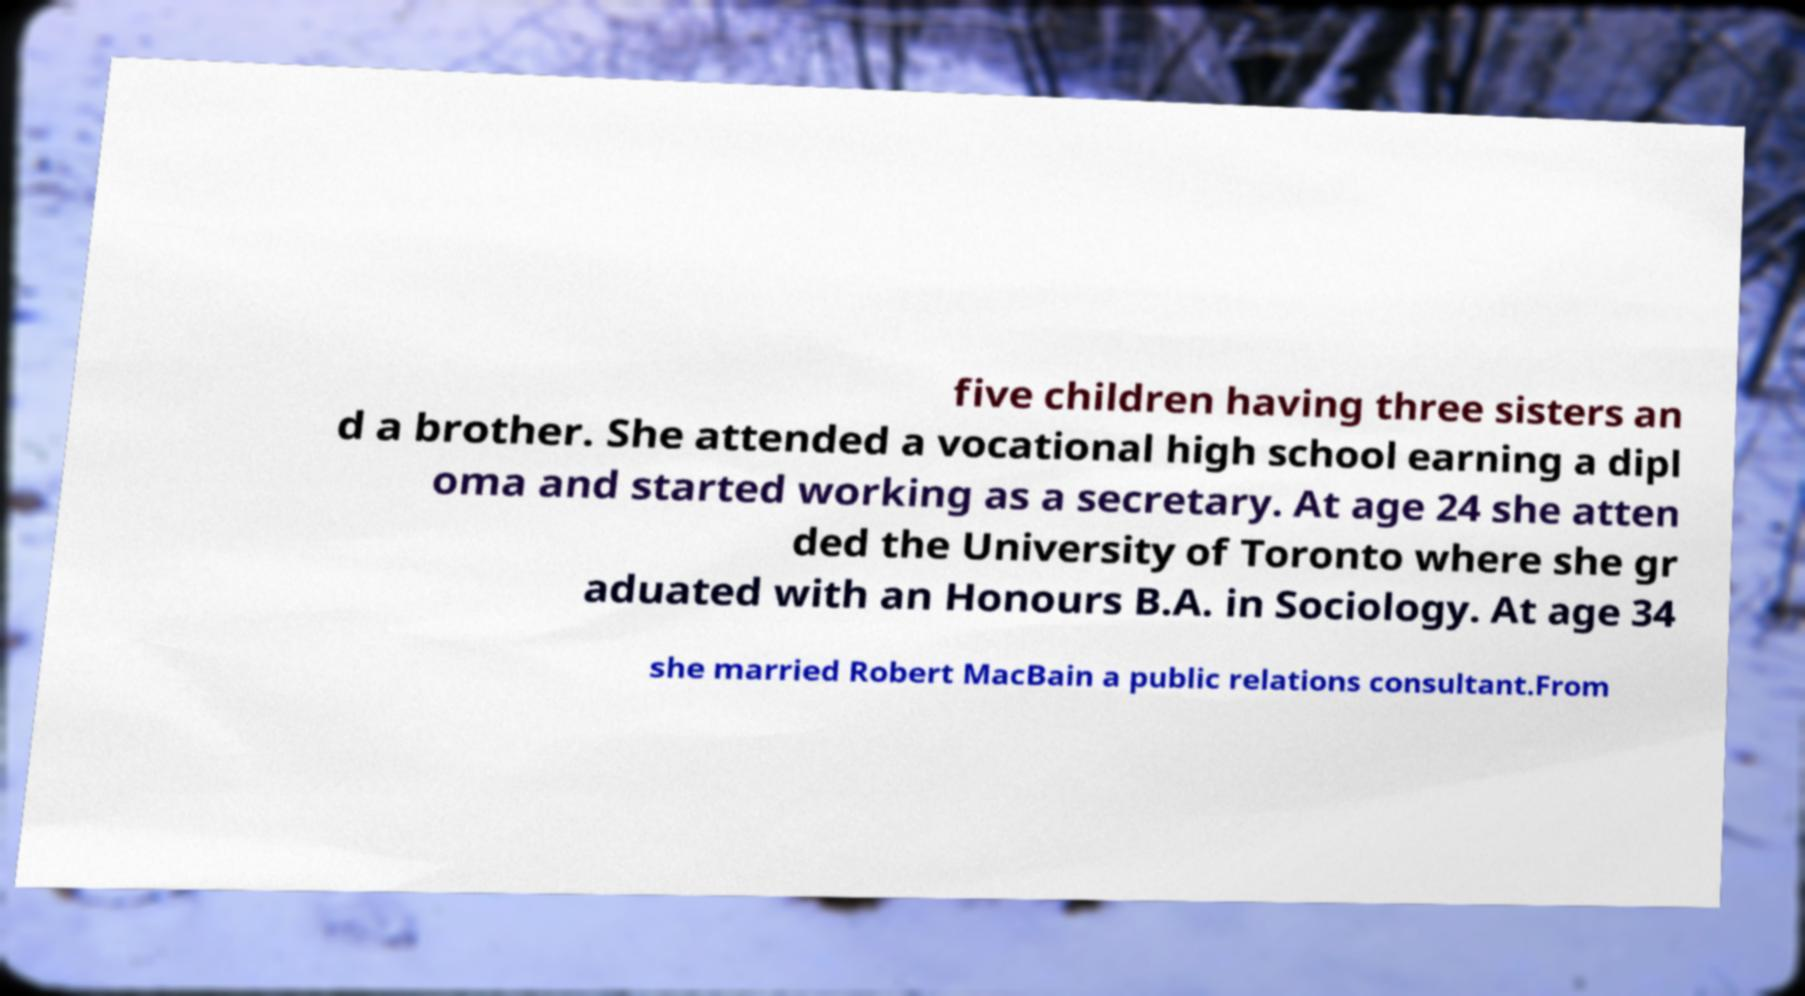What messages or text are displayed in this image? I need them in a readable, typed format. five children having three sisters an d a brother. She attended a vocational high school earning a dipl oma and started working as a secretary. At age 24 she atten ded the University of Toronto where she gr aduated with an Honours B.A. in Sociology. At age 34 she married Robert MacBain a public relations consultant.From 